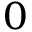<formula> <loc_0><loc_0><loc_500><loc_500>_ { 0 }</formula> 